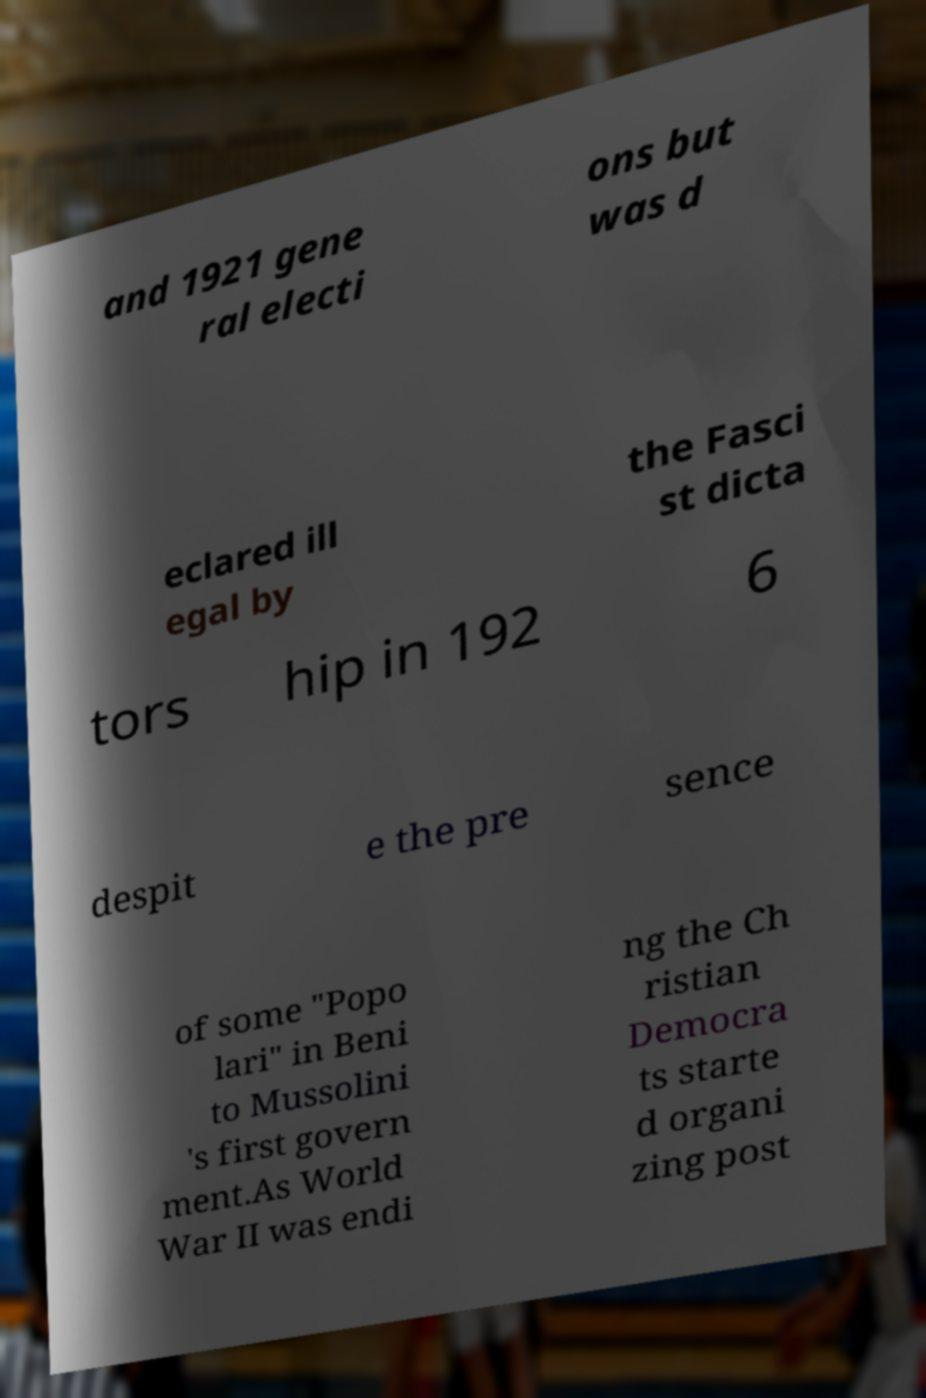Can you accurately transcribe the text from the provided image for me? and 1921 gene ral electi ons but was d eclared ill egal by the Fasci st dicta tors hip in 192 6 despit e the pre sence of some "Popo lari" in Beni to Mussolini 's first govern ment.As World War II was endi ng the Ch ristian Democra ts starte d organi zing post 